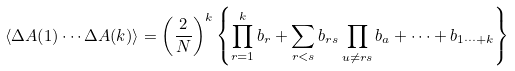Convert formula to latex. <formula><loc_0><loc_0><loc_500><loc_500>\langle \Delta A ( 1 ) \cdots \Delta A ( k ) \rangle = \left ( \frac { 2 } { N } \right ) ^ { k } \left \{ \prod _ { r = 1 } ^ { k } b _ { r } + \sum _ { r < s } b _ { r s } \prod _ { u \neq r s } b _ { a } + \cdots + b _ { 1 \cdots + k } \right \}</formula> 